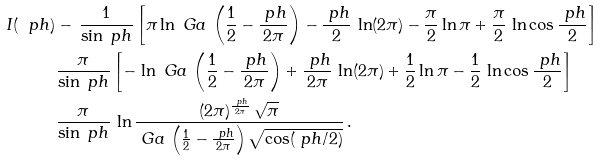Convert formula to latex. <formula><loc_0><loc_0><loc_500><loc_500>I ( \ p h ) & - \, \frac { 1 } { \sin \ p h } \left [ \pi \ln \ G a \, \left ( \frac { 1 } { 2 } - \frac { \ p h } { 2 \pi } \right ) - \frac { \ p h } { 2 } \, \ln ( 2 \pi ) - \frac { \pi } { 2 } \ln \pi + \frac { \pi } { 2 } \, \ln \cos \frac { \ p h } { 2 } \right ] \\ & \frac { \pi } { \sin \ p h } \left [ - \, \ln \ G a \, \left ( \frac { 1 } { 2 } - \frac { \ p h } { 2 \pi } \right ) + \frac { \ p h } { 2 \pi } \, \ln ( 2 \pi ) + \frac { 1 } { 2 } \ln \pi - \frac { 1 } { 2 } \, \ln \cos \frac { \ p h } { 2 } \right ] \\ & \frac { \pi } { \sin \ p h } \, \ln \frac { ( 2 \pi ) ^ { \frac { \ p h } { 2 \pi } } \, \sqrt { \pi } } { \ G a \, \left ( \frac { 1 } { 2 } - \frac { \ p h } { 2 \pi } \right ) \sqrt { \cos ( \ p h / 2 ) } } \, .</formula> 